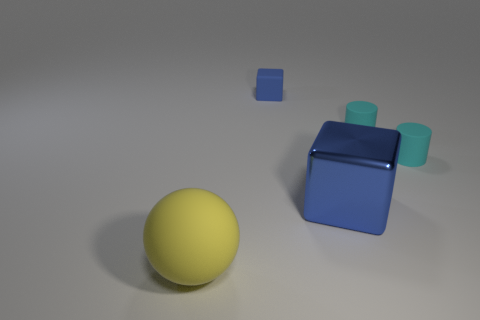How many other objects are there of the same material as the small blue thing?
Offer a very short reply. 3. Is there anything else that has the same shape as the yellow rubber object?
Offer a very short reply. No. Is the size of the rubber block the same as the metallic cube?
Offer a very short reply. No. There is a rubber thing that is both left of the shiny block and in front of the small blue rubber block; what is its size?
Provide a short and direct response. Large. How many metallic things are either big objects or large balls?
Your answer should be compact. 1. Is the number of big things right of the large matte ball greater than the number of green matte balls?
Ensure brevity in your answer.  Yes. What is the material of the large object on the right side of the large sphere?
Make the answer very short. Metal. How many blue things are the same material as the large ball?
Provide a succinct answer. 1. What is the shape of the thing that is left of the blue metallic thing and behind the blue metallic thing?
Ensure brevity in your answer.  Cube. How many objects are big objects behind the big yellow ball or matte cylinders that are behind the sphere?
Make the answer very short. 3. 